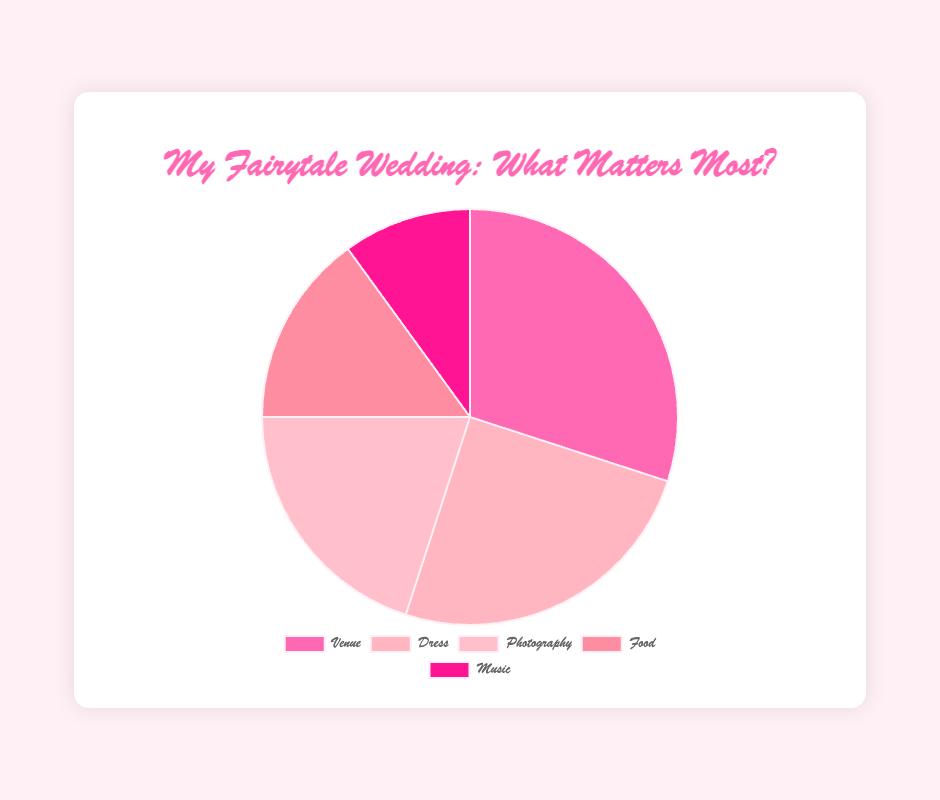Which wedding aspect holds the highest percentage? The chart shows that "Venue" has the biggest section, indicating the highest importance percentage.
Answer: Venue What percentage of importance is given to the Dress? The pie chart has a segment labeled "Dress" which is at 25%.
Answer: 25% How much more important is the Venue compared to Music? The segment for Venue is 30%, and Music is 10%. The difference is 30% - 10% = 20%.
Answer: 20% What's the combined importance percentage of Dress and Photography? Dress is listed as 25% and Photography is 20%. Their combined importance is 25% + 20% = 45%.
Answer: 45% Is Food more or less important than Photography? The pie chart shows that Food has a segment of 15%, while Photography has 20%. Hence, Food is less important than Photography.
Answer: Less important Among the aspects listed, which has the smallest importance percentage, and what is it? The smallest segment on the pie chart represents Music, which has 10%.
Answer: Music, 10% What is the average importance percentage of all the wedding aspects excluding Venue? Excluding Venue, the percentages are 25% (Dress), 20% (Photography), 15% (Food), and 10% (Music). The average is (25% + 20% + 15% + 10%) / 4 = 70% / 4 = 17.5%.
Answer: 17.5% What's the difference in importance between the Dress and Food? The chart shows Dress at 25% and Food at 15%. The difference is 25% - 15% = 10%.
Answer: 10% Which wedding aspect is visually represented by the color closest to pink? Based on the pie chart's color scheme, the Dress segment is closest to pink.
Answer: Dress If you combine the importance of Music and Food, how does it compare to the Dress? Music is 10% and Food is 15%, their combined importance is 10% + 15% = 25%, which is equal to the importance percentage of Dress (25%).
Answer: Equal 